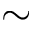Convert formula to latex. <formula><loc_0><loc_0><loc_500><loc_500>\sim</formula> 